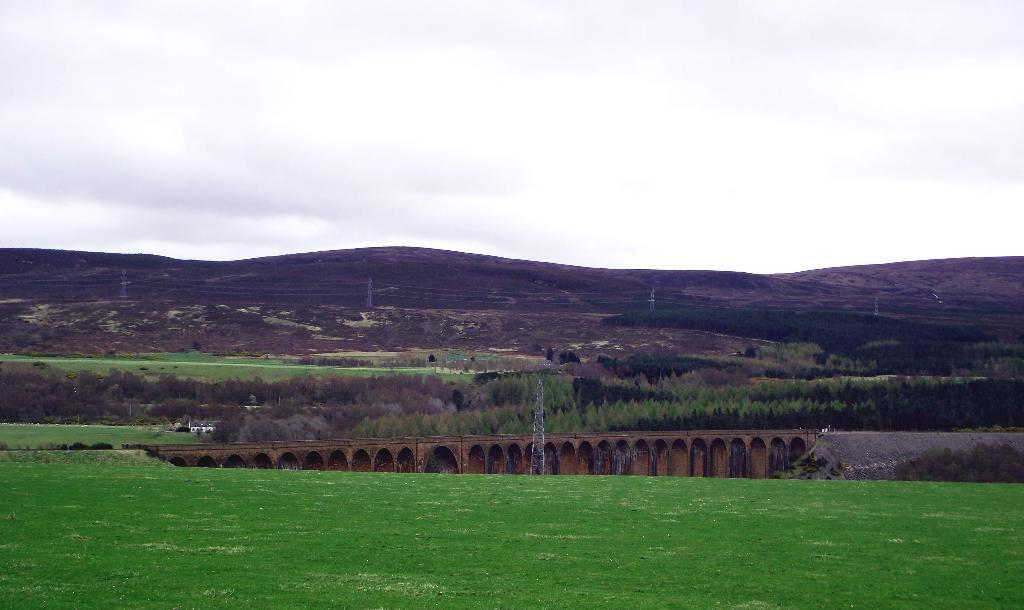Please provide a concise description of this image. In this image we can see electricity towers, grass, bridge, trees, wires, hills, sky and clouds. 